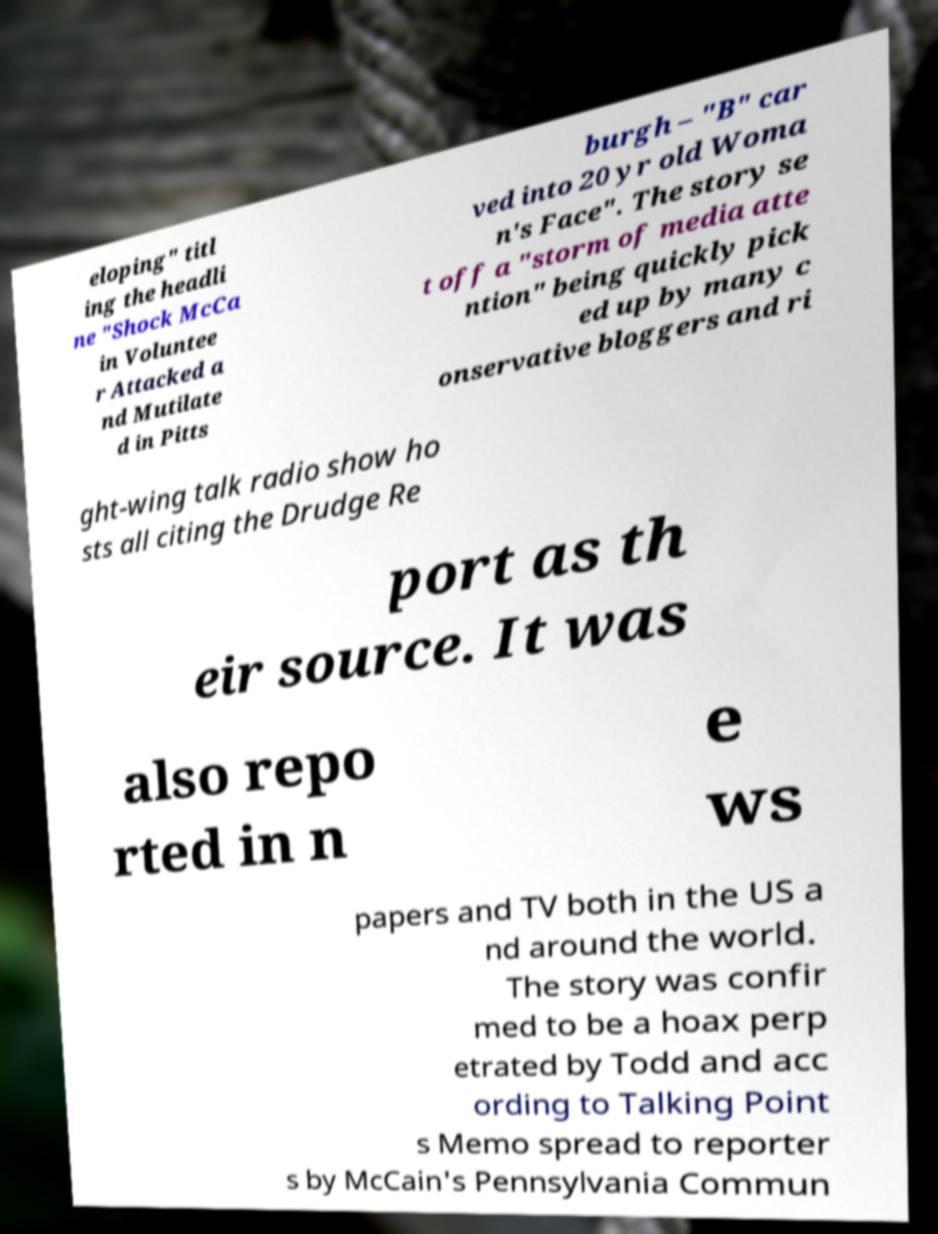Could you extract and type out the text from this image? eloping" titl ing the headli ne "Shock McCa in Voluntee r Attacked a nd Mutilate d in Pitts burgh – "B" car ved into 20 yr old Woma n's Face". The story se t off a "storm of media atte ntion" being quickly pick ed up by many c onservative bloggers and ri ght-wing talk radio show ho sts all citing the Drudge Re port as th eir source. It was also repo rted in n e ws papers and TV both in the US a nd around the world. The story was confir med to be a hoax perp etrated by Todd and acc ording to Talking Point s Memo spread to reporter s by McCain's Pennsylvania Commun 